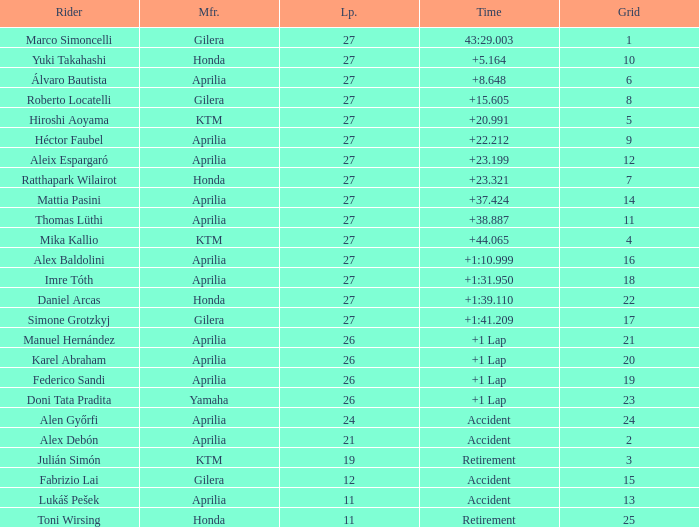Which Manufacturer has a Time of accident and a Grid greater than 15? Aprilia. 